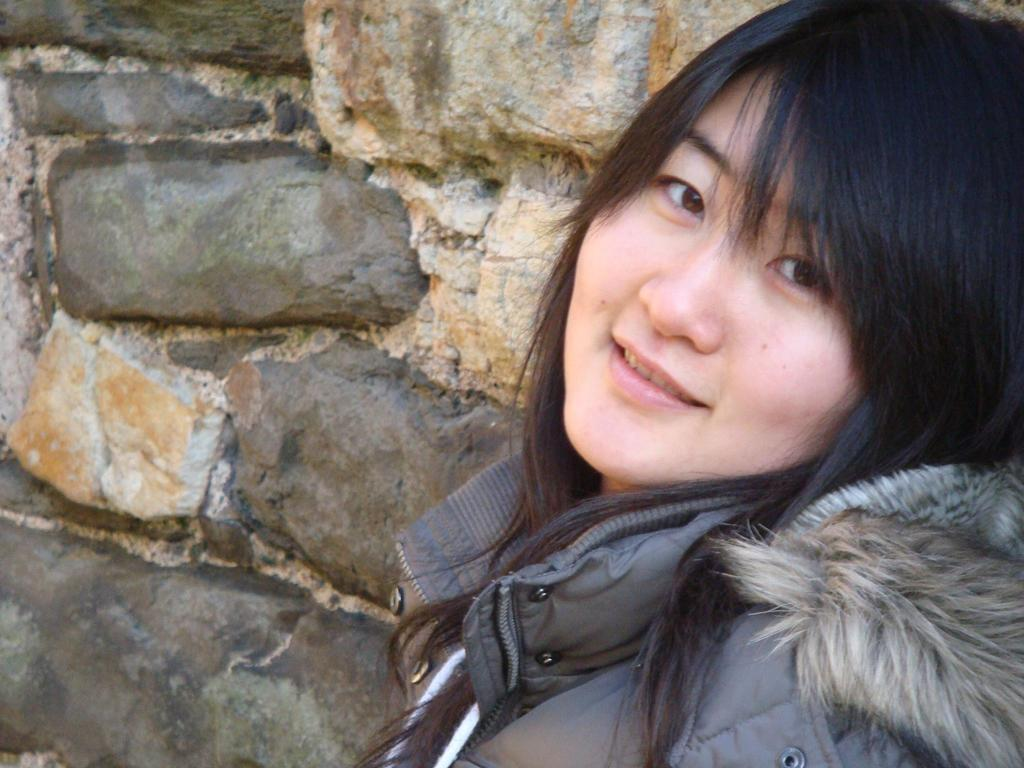Who is the main subject in the foreground of the image? There is a woman in the foreground of the image. What is the woman wearing in the image? The woman is wearing a jacket in the image. Can you describe the woman's hair color? The woman has black hair in the image. What can be seen in the background of the image? There is a wall in the background of the image. What type of toothpaste is the woman using in the image? There is no toothpaste present in the image; it features a woman in the foreground wearing a jacket and standing in front of a wall. Can you tell me how many goats are visible in the image? There are no goats present in the image. 